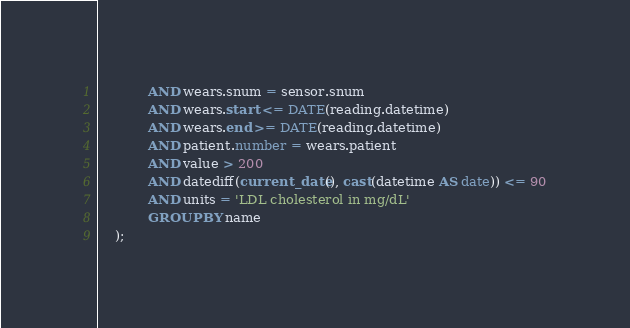<code> <loc_0><loc_0><loc_500><loc_500><_SQL_>            AND wears.snum = sensor.snum
            AND wears.start <= DATE(reading.datetime)
            AND wears.end >= DATE(reading.datetime)
            AND patient.number = wears.patient
            AND value > 200
            AND datediff(current_date(), cast(datetime AS date)) <= 90
            AND units = 'LDL cholesterol in mg/dL'
            GROUP BY name
    );</code> 